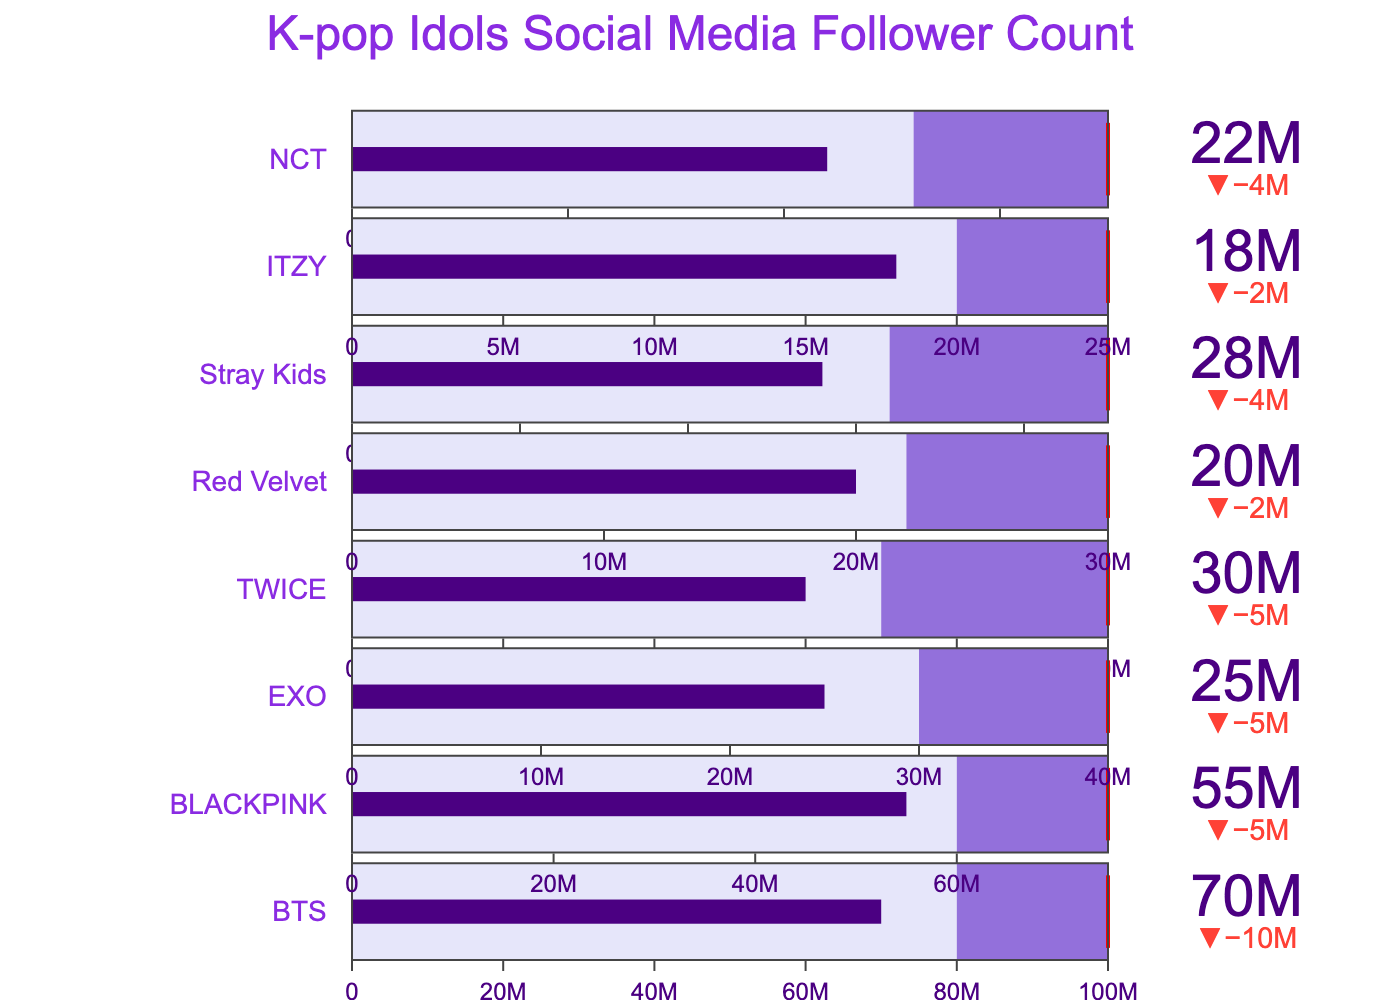what is the title of this bullet chart? The title is located at the top center of the chart. It reads "K-pop Idols Social Media Follower Count".
Answer: K-pop Idols Social Media Follower Count What is the target follower count for BTS? The target value is displayed by the red threshold line in the bullet chart for BTS. This is indicated at 100,000,000 followers.
Answer: 100,000,000 Who has the current highest follower count among the listed K-pop idols? The K-pop idol with the highest current follower count is indicated by the highest bar in the bullet chart. BTS has the highest with 70,000,000 followers.
Answer: BTS What color represents the section between the current and comparison follower counts? The section between the current and comparison follower counts is colored in light purple in the bullet chart.
Answer: light purple How many followers, more than the comparison figure, does BLACKPINK currently have? The difference in follower count from the comparison figure for BLACKPINK can be calculated as 55,000,000 (current) - 60,000,000 (comparison) = -5,000,000.
Answer: -5,000,000 Which K-pop idol is the closest to reaching their target follower count? The K-pop idol closest to their target can be identified by seeing which bar is closest to its respective red threshold line. TWICE is most closely approaching their target of 50,000,000 with 30,000,000 followers.
Answer: TWICE How does EXO’s follower count compare to its target? EXO’s follower count is currently 25,000,000, while their target is 40,000,000, so they are 15,000,000 followers short of the target.
Answer: 15,000,000 followers short Whose current follower count is the lowest among the K-pop idols listed? The K-pop idol with the lowest current follower count is indicated by the shortest bar in the bullet chart. ITZY has the lowest with 18,000,000 followers.
Answer: ITZY By how many followers does NCT need to increase their followers to reach their current target? To calculate how many more followers NCT needs, subtract their current followers from their target: 35,000,000 (target) - 22,000,000 (current) = 13,000,000.
Answer: 13,000,000 What is the range for the gauge in TWICE's bullet chart? The range for the gauge in TWICE’s bullet chart extends from 0 to their target follower count which is 50,000,000.
Answer: 0 to 50,000,000 